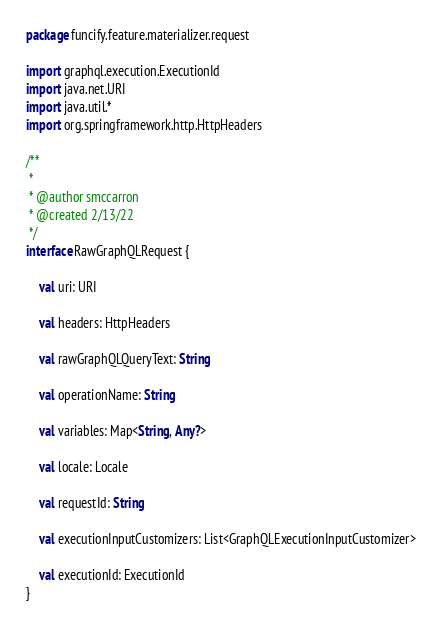Convert code to text. <code><loc_0><loc_0><loc_500><loc_500><_Kotlin_>package funcify.feature.materializer.request

import graphql.execution.ExecutionId
import java.net.URI
import java.util.*
import org.springframework.http.HttpHeaders

/**
 *
 * @author smccarron
 * @created 2/13/22
 */
interface RawGraphQLRequest {

    val uri: URI

    val headers: HttpHeaders

    val rawGraphQLQueryText: String

    val operationName: String

    val variables: Map<String, Any?>

    val locale: Locale

    val requestId: String

    val executionInputCustomizers: List<GraphQLExecutionInputCustomizer>

    val executionId: ExecutionId
}
</code> 